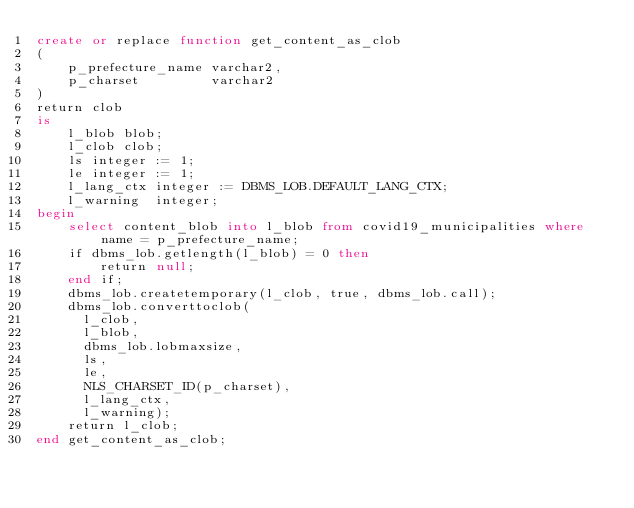Convert code to text. <code><loc_0><loc_0><loc_500><loc_500><_SQL_>create or replace function get_content_as_clob
(
    p_prefecture_name varchar2,
    p_charset         varchar2
)
return clob
is
    l_blob blob;
    l_clob clob;
    ls integer := 1;
    le integer := 1;
    l_lang_ctx integer := DBMS_LOB.DEFAULT_LANG_CTX;
    l_warning  integer;
begin
    select content_blob into l_blob from covid19_municipalities where name = p_prefecture_name;
    if dbms_lob.getlength(l_blob) = 0 then
        return null;
    end if;
    dbms_lob.createtemporary(l_clob, true, dbms_lob.call);
    dbms_lob.converttoclob(
      l_clob,
      l_blob,
      dbms_lob.lobmaxsize,
      ls,
      le,
      NLS_CHARSET_ID(p_charset),
      l_lang_ctx,
      l_warning);
    return l_clob;
end get_content_as_clob;
</code> 